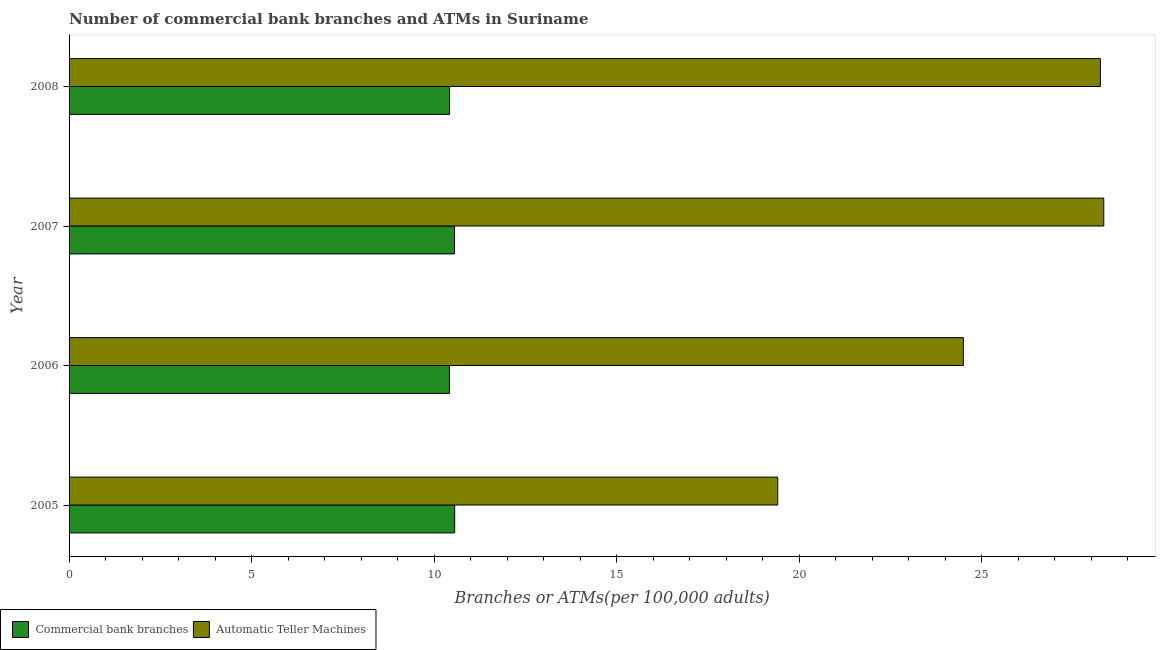How many groups of bars are there?
Your answer should be very brief. 4. Are the number of bars per tick equal to the number of legend labels?
Offer a terse response. Yes. How many bars are there on the 1st tick from the top?
Your answer should be compact. 2. How many bars are there on the 4th tick from the bottom?
Offer a very short reply. 2. What is the label of the 4th group of bars from the top?
Make the answer very short. 2005. In how many cases, is the number of bars for a given year not equal to the number of legend labels?
Keep it short and to the point. 0. What is the number of commercal bank branches in 2006?
Provide a short and direct response. 10.42. Across all years, what is the maximum number of commercal bank branches?
Make the answer very short. 10.56. Across all years, what is the minimum number of atms?
Ensure brevity in your answer.  19.41. In which year was the number of commercal bank branches minimum?
Give a very brief answer. 2006. What is the total number of commercal bank branches in the graph?
Ensure brevity in your answer.  41.96. What is the difference between the number of atms in 2007 and that in 2008?
Your answer should be very brief. 0.09. What is the difference between the number of atms in 2005 and the number of commercal bank branches in 2006?
Make the answer very short. 9. What is the average number of commercal bank branches per year?
Your answer should be very brief. 10.49. In the year 2008, what is the difference between the number of atms and number of commercal bank branches?
Offer a very short reply. 17.83. What is the ratio of the number of atms in 2006 to that in 2007?
Keep it short and to the point. 0.86. Is the number of commercal bank branches in 2005 less than that in 2006?
Your response must be concise. No. Is the difference between the number of atms in 2007 and 2008 greater than the difference between the number of commercal bank branches in 2007 and 2008?
Offer a very short reply. No. What is the difference between the highest and the second highest number of atms?
Provide a succinct answer. 0.09. What is the difference between the highest and the lowest number of atms?
Ensure brevity in your answer.  8.93. In how many years, is the number of atms greater than the average number of atms taken over all years?
Provide a short and direct response. 2. What does the 2nd bar from the top in 2008 represents?
Provide a succinct answer. Commercial bank branches. What does the 2nd bar from the bottom in 2008 represents?
Offer a terse response. Automatic Teller Machines. How many bars are there?
Offer a very short reply. 8. How many years are there in the graph?
Offer a terse response. 4. What is the difference between two consecutive major ticks on the X-axis?
Provide a short and direct response. 5. Does the graph contain any zero values?
Ensure brevity in your answer.  No. Where does the legend appear in the graph?
Provide a succinct answer. Bottom left. How are the legend labels stacked?
Your answer should be compact. Horizontal. What is the title of the graph?
Give a very brief answer. Number of commercial bank branches and ATMs in Suriname. Does "Private creditors" appear as one of the legend labels in the graph?
Provide a succinct answer. No. What is the label or title of the X-axis?
Ensure brevity in your answer.  Branches or ATMs(per 100,0 adults). What is the label or title of the Y-axis?
Your answer should be very brief. Year. What is the Branches or ATMs(per 100,000 adults) of Commercial bank branches in 2005?
Ensure brevity in your answer.  10.56. What is the Branches or ATMs(per 100,000 adults) of Automatic Teller Machines in 2005?
Offer a terse response. 19.41. What is the Branches or ATMs(per 100,000 adults) of Commercial bank branches in 2006?
Your response must be concise. 10.42. What is the Branches or ATMs(per 100,000 adults) of Automatic Teller Machines in 2006?
Your answer should be very brief. 24.5. What is the Branches or ATMs(per 100,000 adults) in Commercial bank branches in 2007?
Your answer should be compact. 10.56. What is the Branches or ATMs(per 100,000 adults) of Automatic Teller Machines in 2007?
Offer a terse response. 28.34. What is the Branches or ATMs(per 100,000 adults) in Commercial bank branches in 2008?
Your response must be concise. 10.42. What is the Branches or ATMs(per 100,000 adults) in Automatic Teller Machines in 2008?
Provide a short and direct response. 28.25. Across all years, what is the maximum Branches or ATMs(per 100,000 adults) of Commercial bank branches?
Provide a short and direct response. 10.56. Across all years, what is the maximum Branches or ATMs(per 100,000 adults) of Automatic Teller Machines?
Make the answer very short. 28.34. Across all years, what is the minimum Branches or ATMs(per 100,000 adults) in Commercial bank branches?
Offer a very short reply. 10.42. Across all years, what is the minimum Branches or ATMs(per 100,000 adults) of Automatic Teller Machines?
Offer a terse response. 19.41. What is the total Branches or ATMs(per 100,000 adults) of Commercial bank branches in the graph?
Your answer should be very brief. 41.96. What is the total Branches or ATMs(per 100,000 adults) in Automatic Teller Machines in the graph?
Provide a succinct answer. 100.5. What is the difference between the Branches or ATMs(per 100,000 adults) in Commercial bank branches in 2005 and that in 2006?
Keep it short and to the point. 0.14. What is the difference between the Branches or ATMs(per 100,000 adults) of Automatic Teller Machines in 2005 and that in 2006?
Your response must be concise. -5.08. What is the difference between the Branches or ATMs(per 100,000 adults) of Commercial bank branches in 2005 and that in 2007?
Your answer should be very brief. 0. What is the difference between the Branches or ATMs(per 100,000 adults) of Automatic Teller Machines in 2005 and that in 2007?
Keep it short and to the point. -8.93. What is the difference between the Branches or ATMs(per 100,000 adults) in Commercial bank branches in 2005 and that in 2008?
Make the answer very short. 0.14. What is the difference between the Branches or ATMs(per 100,000 adults) of Automatic Teller Machines in 2005 and that in 2008?
Offer a terse response. -8.84. What is the difference between the Branches or ATMs(per 100,000 adults) in Commercial bank branches in 2006 and that in 2007?
Your response must be concise. -0.14. What is the difference between the Branches or ATMs(per 100,000 adults) in Automatic Teller Machines in 2006 and that in 2007?
Make the answer very short. -3.85. What is the difference between the Branches or ATMs(per 100,000 adults) of Commercial bank branches in 2006 and that in 2008?
Make the answer very short. -0. What is the difference between the Branches or ATMs(per 100,000 adults) of Automatic Teller Machines in 2006 and that in 2008?
Make the answer very short. -3.75. What is the difference between the Branches or ATMs(per 100,000 adults) in Commercial bank branches in 2007 and that in 2008?
Make the answer very short. 0.14. What is the difference between the Branches or ATMs(per 100,000 adults) of Automatic Teller Machines in 2007 and that in 2008?
Provide a succinct answer. 0.09. What is the difference between the Branches or ATMs(per 100,000 adults) in Commercial bank branches in 2005 and the Branches or ATMs(per 100,000 adults) in Automatic Teller Machines in 2006?
Give a very brief answer. -13.93. What is the difference between the Branches or ATMs(per 100,000 adults) in Commercial bank branches in 2005 and the Branches or ATMs(per 100,000 adults) in Automatic Teller Machines in 2007?
Your response must be concise. -17.78. What is the difference between the Branches or ATMs(per 100,000 adults) of Commercial bank branches in 2005 and the Branches or ATMs(per 100,000 adults) of Automatic Teller Machines in 2008?
Your response must be concise. -17.69. What is the difference between the Branches or ATMs(per 100,000 adults) of Commercial bank branches in 2006 and the Branches or ATMs(per 100,000 adults) of Automatic Teller Machines in 2007?
Make the answer very short. -17.92. What is the difference between the Branches or ATMs(per 100,000 adults) of Commercial bank branches in 2006 and the Branches or ATMs(per 100,000 adults) of Automatic Teller Machines in 2008?
Give a very brief answer. -17.83. What is the difference between the Branches or ATMs(per 100,000 adults) of Commercial bank branches in 2007 and the Branches or ATMs(per 100,000 adults) of Automatic Teller Machines in 2008?
Provide a succinct answer. -17.69. What is the average Branches or ATMs(per 100,000 adults) in Commercial bank branches per year?
Provide a succinct answer. 10.49. What is the average Branches or ATMs(per 100,000 adults) in Automatic Teller Machines per year?
Keep it short and to the point. 25.13. In the year 2005, what is the difference between the Branches or ATMs(per 100,000 adults) in Commercial bank branches and Branches or ATMs(per 100,000 adults) in Automatic Teller Machines?
Your response must be concise. -8.85. In the year 2006, what is the difference between the Branches or ATMs(per 100,000 adults) of Commercial bank branches and Branches or ATMs(per 100,000 adults) of Automatic Teller Machines?
Your answer should be very brief. -14.08. In the year 2007, what is the difference between the Branches or ATMs(per 100,000 adults) of Commercial bank branches and Branches or ATMs(per 100,000 adults) of Automatic Teller Machines?
Your answer should be compact. -17.78. In the year 2008, what is the difference between the Branches or ATMs(per 100,000 adults) of Commercial bank branches and Branches or ATMs(per 100,000 adults) of Automatic Teller Machines?
Make the answer very short. -17.83. What is the ratio of the Branches or ATMs(per 100,000 adults) of Commercial bank branches in 2005 to that in 2006?
Your answer should be very brief. 1.01. What is the ratio of the Branches or ATMs(per 100,000 adults) of Automatic Teller Machines in 2005 to that in 2006?
Ensure brevity in your answer.  0.79. What is the ratio of the Branches or ATMs(per 100,000 adults) in Automatic Teller Machines in 2005 to that in 2007?
Offer a terse response. 0.69. What is the ratio of the Branches or ATMs(per 100,000 adults) in Commercial bank branches in 2005 to that in 2008?
Your answer should be compact. 1.01. What is the ratio of the Branches or ATMs(per 100,000 adults) of Automatic Teller Machines in 2005 to that in 2008?
Provide a succinct answer. 0.69. What is the ratio of the Branches or ATMs(per 100,000 adults) in Commercial bank branches in 2006 to that in 2007?
Your answer should be compact. 0.99. What is the ratio of the Branches or ATMs(per 100,000 adults) in Automatic Teller Machines in 2006 to that in 2007?
Give a very brief answer. 0.86. What is the ratio of the Branches or ATMs(per 100,000 adults) of Automatic Teller Machines in 2006 to that in 2008?
Keep it short and to the point. 0.87. What is the ratio of the Branches or ATMs(per 100,000 adults) in Commercial bank branches in 2007 to that in 2008?
Offer a very short reply. 1.01. What is the difference between the highest and the second highest Branches or ATMs(per 100,000 adults) of Commercial bank branches?
Ensure brevity in your answer.  0. What is the difference between the highest and the second highest Branches or ATMs(per 100,000 adults) in Automatic Teller Machines?
Offer a terse response. 0.09. What is the difference between the highest and the lowest Branches or ATMs(per 100,000 adults) in Commercial bank branches?
Give a very brief answer. 0.14. What is the difference between the highest and the lowest Branches or ATMs(per 100,000 adults) of Automatic Teller Machines?
Provide a succinct answer. 8.93. 